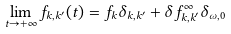Convert formula to latex. <formula><loc_0><loc_0><loc_500><loc_500>\lim _ { t \to + \infty } f _ { k , k ^ { \prime } } ( t ) = f _ { k } \delta _ { k , k ^ { \prime } } + \delta f ^ { \infty } _ { k , k ^ { \prime } } \delta _ { \omega , 0 }</formula> 